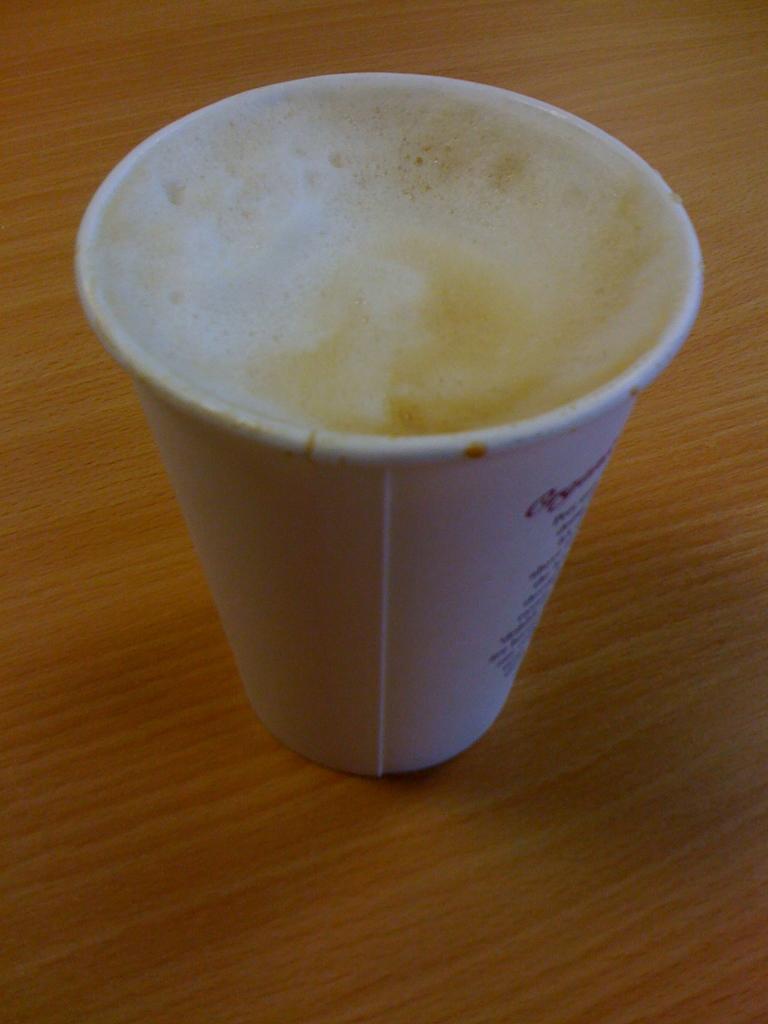Can you describe this image briefly? In this image we can see a cup on a wooden surface. Inside the cup we can see foam. 